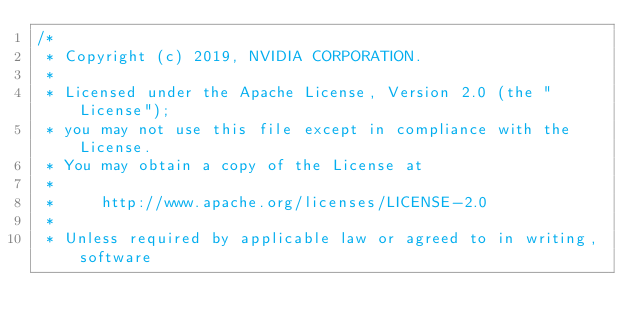<code> <loc_0><loc_0><loc_500><loc_500><_Cuda_>/*
 * Copyright (c) 2019, NVIDIA CORPORATION.
 *
 * Licensed under the Apache License, Version 2.0 (the "License");
 * you may not use this file except in compliance with the License.
 * You may obtain a copy of the License at
 *
 *     http://www.apache.org/licenses/LICENSE-2.0
 *
 * Unless required by applicable law or agreed to in writing, software</code> 